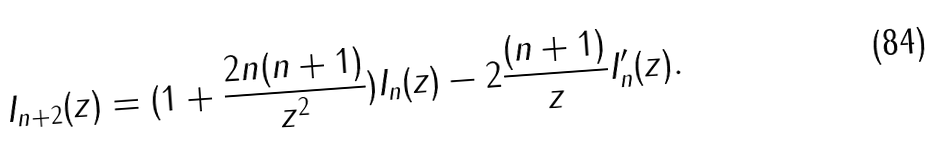Convert formula to latex. <formula><loc_0><loc_0><loc_500><loc_500>I _ { n + 2 } ( z ) = ( 1 + \frac { 2 n ( n + 1 ) } { z ^ { 2 } } ) I _ { n } ( z ) - 2 \frac { ( n + 1 ) } { z } I _ { n } ^ { \prime } ( z ) .</formula> 